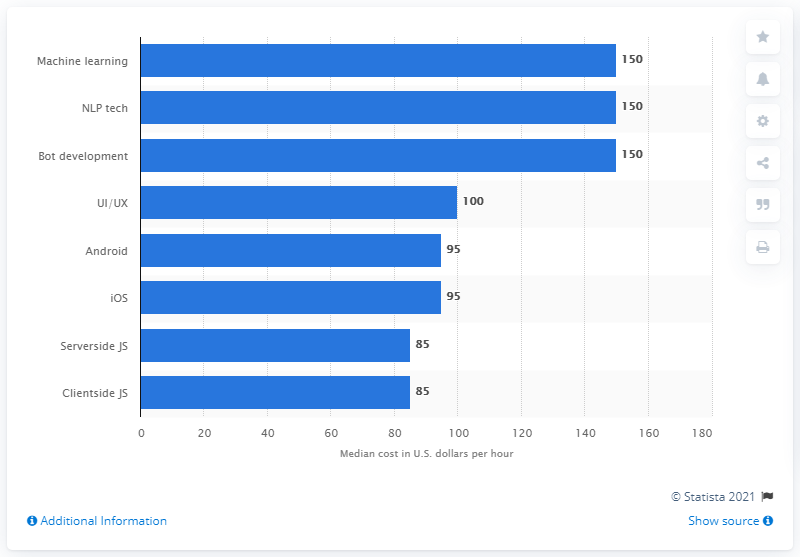Mention a couple of crucial points in this snapshot. The median cost per hour for iOS app development was $95. 